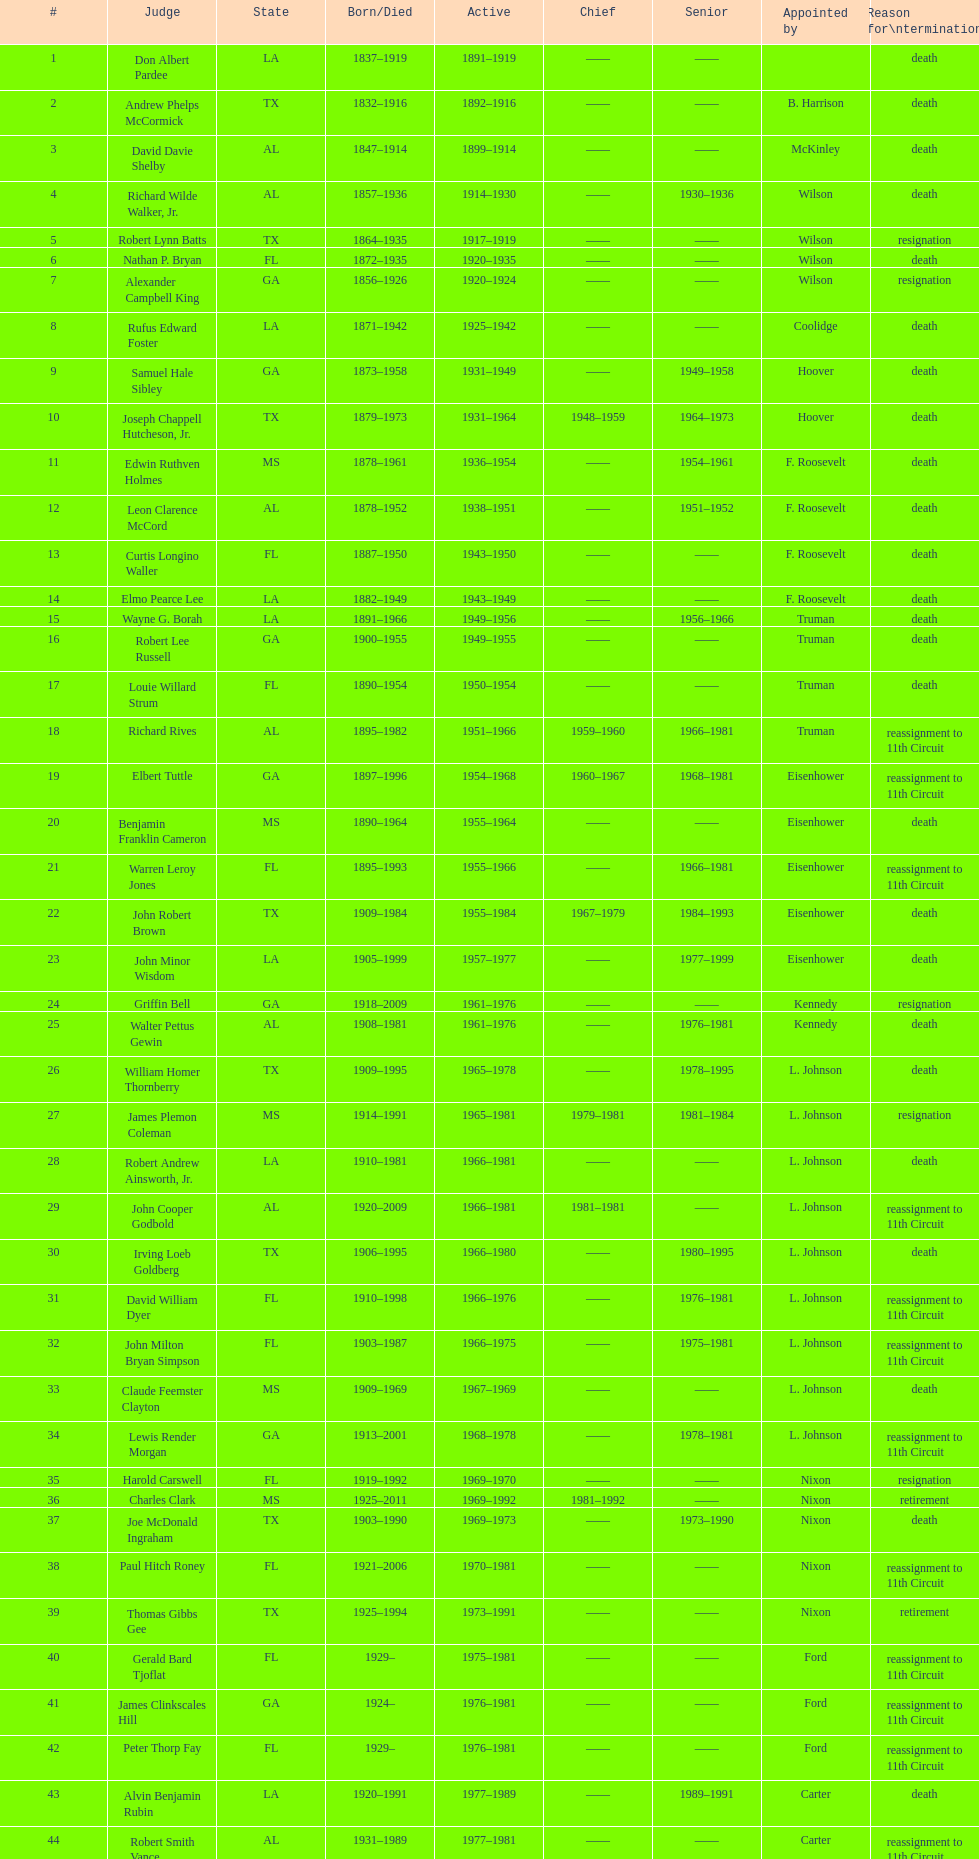How many judges served as chief total? 8. 